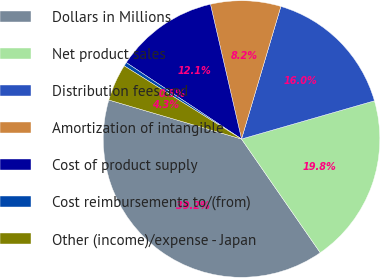Convert chart. <chart><loc_0><loc_0><loc_500><loc_500><pie_chart><fcel>Dollars in Millions<fcel>Net product sales<fcel>Distribution fees and<fcel>Amortization of intangible<fcel>Cost of product supply<fcel>Cost reimbursements to/(from)<fcel>Other (income)/expense - Japan<nl><fcel>39.19%<fcel>19.82%<fcel>15.95%<fcel>8.2%<fcel>12.07%<fcel>0.45%<fcel>4.32%<nl></chart> 